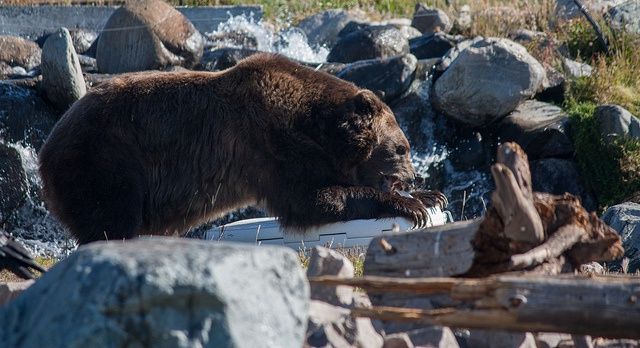Describe the objects in this image and their specific colors. I can see a bear in gray, black, and darkgray tones in this image. 